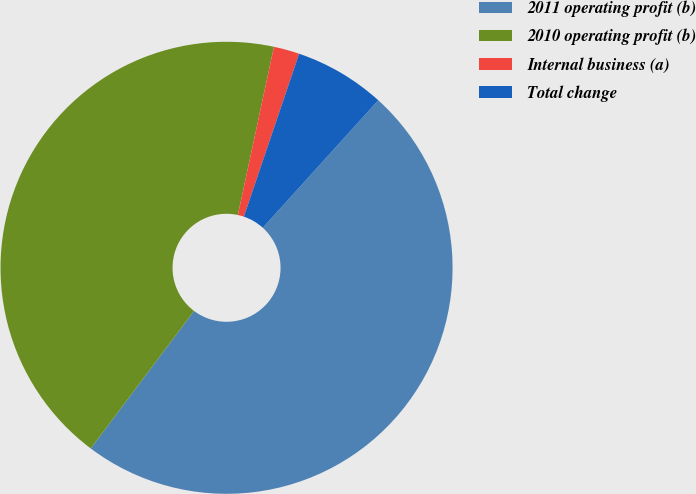Convert chart. <chart><loc_0><loc_0><loc_500><loc_500><pie_chart><fcel>2011 operating profit (b)<fcel>2010 operating profit (b)<fcel>Internal business (a)<fcel>Total change<nl><fcel>48.54%<fcel>43.1%<fcel>1.84%<fcel>6.51%<nl></chart> 